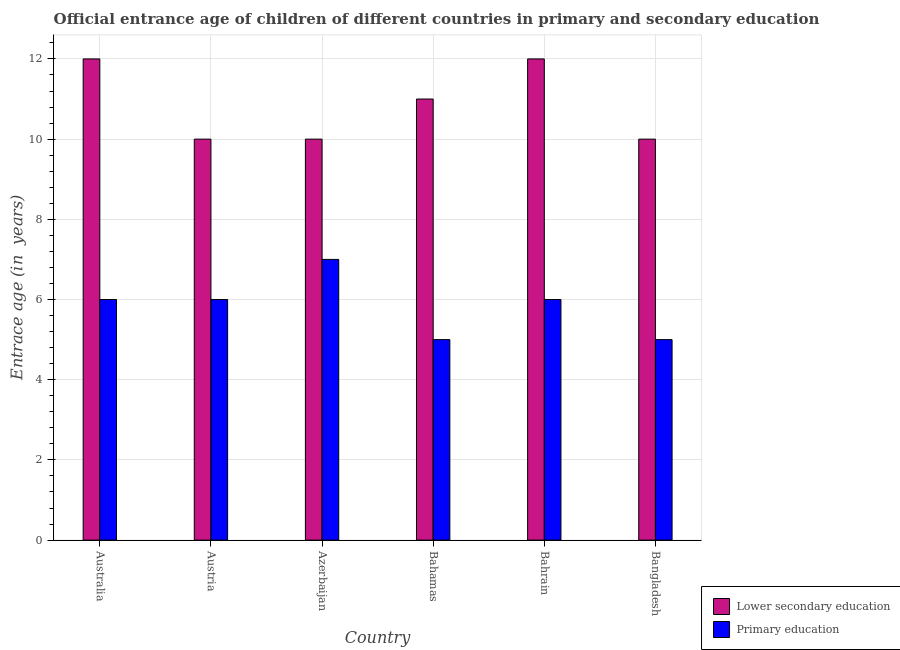Are the number of bars per tick equal to the number of legend labels?
Give a very brief answer. Yes. Are the number of bars on each tick of the X-axis equal?
Provide a short and direct response. Yes. How many bars are there on the 3rd tick from the right?
Offer a terse response. 2. What is the label of the 3rd group of bars from the left?
Your response must be concise. Azerbaijan. What is the entrance age of children in lower secondary education in Australia?
Your answer should be very brief. 12. Across all countries, what is the maximum entrance age of children in lower secondary education?
Ensure brevity in your answer.  12. Across all countries, what is the minimum entrance age of children in lower secondary education?
Ensure brevity in your answer.  10. In which country was the entrance age of chiildren in primary education maximum?
Ensure brevity in your answer.  Azerbaijan. In which country was the entrance age of children in lower secondary education minimum?
Offer a terse response. Austria. What is the total entrance age of chiildren in primary education in the graph?
Offer a very short reply. 35. What is the difference between the entrance age of chiildren in primary education in Bahrain and that in Bangladesh?
Your answer should be very brief. 1. What is the difference between the entrance age of children in lower secondary education in Australia and the entrance age of chiildren in primary education in Austria?
Offer a terse response. 6. What is the average entrance age of children in lower secondary education per country?
Make the answer very short. 10.83. In how many countries, is the entrance age of children in lower secondary education greater than 3.6 years?
Keep it short and to the point. 6. What is the ratio of the entrance age of children in lower secondary education in Bahamas to that in Bahrain?
Offer a terse response. 0.92. Is the difference between the entrance age of chiildren in primary education in Austria and Bahamas greater than the difference between the entrance age of children in lower secondary education in Austria and Bahamas?
Offer a terse response. Yes. What is the difference between the highest and the second highest entrance age of chiildren in primary education?
Provide a succinct answer. 1. What is the difference between the highest and the lowest entrance age of children in lower secondary education?
Your answer should be very brief. 2. What does the 1st bar from the left in Austria represents?
Your answer should be compact. Lower secondary education. What does the 1st bar from the right in Bahrain represents?
Keep it short and to the point. Primary education. What is the difference between two consecutive major ticks on the Y-axis?
Offer a terse response. 2. Does the graph contain any zero values?
Your answer should be very brief. No. Where does the legend appear in the graph?
Your answer should be very brief. Bottom right. How are the legend labels stacked?
Offer a terse response. Vertical. What is the title of the graph?
Ensure brevity in your answer.  Official entrance age of children of different countries in primary and secondary education. What is the label or title of the Y-axis?
Your response must be concise. Entrace age (in  years). What is the Entrace age (in  years) of Primary education in Australia?
Ensure brevity in your answer.  6. What is the Entrace age (in  years) of Lower secondary education in Austria?
Keep it short and to the point. 10. What is the Entrace age (in  years) in Primary education in Austria?
Offer a terse response. 6. What is the Entrace age (in  years) of Primary education in Bahamas?
Offer a terse response. 5. What is the Entrace age (in  years) in Lower secondary education in Bahrain?
Provide a short and direct response. 12. What is the Entrace age (in  years) in Lower secondary education in Bangladesh?
Make the answer very short. 10. What is the Entrace age (in  years) in Primary education in Bangladesh?
Your response must be concise. 5. Across all countries, what is the maximum Entrace age (in  years) of Primary education?
Provide a short and direct response. 7. Across all countries, what is the minimum Entrace age (in  years) of Lower secondary education?
Offer a terse response. 10. What is the total Entrace age (in  years) of Lower secondary education in the graph?
Provide a succinct answer. 65. What is the total Entrace age (in  years) in Primary education in the graph?
Make the answer very short. 35. What is the difference between the Entrace age (in  years) of Primary education in Australia and that in Austria?
Your answer should be compact. 0. What is the difference between the Entrace age (in  years) in Lower secondary education in Australia and that in Azerbaijan?
Your answer should be compact. 2. What is the difference between the Entrace age (in  years) of Primary education in Australia and that in Azerbaijan?
Keep it short and to the point. -1. What is the difference between the Entrace age (in  years) in Lower secondary education in Australia and that in Bahamas?
Provide a succinct answer. 1. What is the difference between the Entrace age (in  years) of Lower secondary education in Australia and that in Bahrain?
Provide a succinct answer. 0. What is the difference between the Entrace age (in  years) in Primary education in Australia and that in Bahrain?
Your response must be concise. 0. What is the difference between the Entrace age (in  years) in Lower secondary education in Australia and that in Bangladesh?
Your answer should be compact. 2. What is the difference between the Entrace age (in  years) in Lower secondary education in Austria and that in Azerbaijan?
Provide a succinct answer. 0. What is the difference between the Entrace age (in  years) in Lower secondary education in Austria and that in Bahamas?
Keep it short and to the point. -1. What is the difference between the Entrace age (in  years) of Lower secondary education in Austria and that in Bahrain?
Offer a very short reply. -2. What is the difference between the Entrace age (in  years) in Lower secondary education in Azerbaijan and that in Bahamas?
Ensure brevity in your answer.  -1. What is the difference between the Entrace age (in  years) in Primary education in Azerbaijan and that in Bahamas?
Keep it short and to the point. 2. What is the difference between the Entrace age (in  years) in Primary education in Azerbaijan and that in Bahrain?
Offer a terse response. 1. What is the difference between the Entrace age (in  years) in Primary education in Azerbaijan and that in Bangladesh?
Ensure brevity in your answer.  2. What is the difference between the Entrace age (in  years) of Lower secondary education in Bahamas and that in Bahrain?
Give a very brief answer. -1. What is the difference between the Entrace age (in  years) in Primary education in Bahamas and that in Bahrain?
Provide a succinct answer. -1. What is the difference between the Entrace age (in  years) of Lower secondary education in Bahrain and that in Bangladesh?
Provide a succinct answer. 2. What is the difference between the Entrace age (in  years) of Lower secondary education in Australia and the Entrace age (in  years) of Primary education in Bahamas?
Offer a very short reply. 7. What is the difference between the Entrace age (in  years) in Lower secondary education in Australia and the Entrace age (in  years) in Primary education in Bahrain?
Keep it short and to the point. 6. What is the difference between the Entrace age (in  years) in Lower secondary education in Austria and the Entrace age (in  years) in Primary education in Azerbaijan?
Provide a short and direct response. 3. What is the difference between the Entrace age (in  years) of Lower secondary education in Austria and the Entrace age (in  years) of Primary education in Bahamas?
Give a very brief answer. 5. What is the difference between the Entrace age (in  years) in Lower secondary education in Austria and the Entrace age (in  years) in Primary education in Bahrain?
Your response must be concise. 4. What is the difference between the Entrace age (in  years) of Lower secondary education in Azerbaijan and the Entrace age (in  years) of Primary education in Bahamas?
Keep it short and to the point. 5. What is the difference between the Entrace age (in  years) of Lower secondary education in Bahamas and the Entrace age (in  years) of Primary education in Bangladesh?
Your answer should be very brief. 6. What is the average Entrace age (in  years) in Lower secondary education per country?
Keep it short and to the point. 10.83. What is the average Entrace age (in  years) in Primary education per country?
Provide a succinct answer. 5.83. What is the difference between the Entrace age (in  years) in Lower secondary education and Entrace age (in  years) in Primary education in Australia?
Provide a succinct answer. 6. What is the difference between the Entrace age (in  years) in Lower secondary education and Entrace age (in  years) in Primary education in Bahamas?
Provide a short and direct response. 6. What is the difference between the Entrace age (in  years) in Lower secondary education and Entrace age (in  years) in Primary education in Bangladesh?
Your response must be concise. 5. What is the ratio of the Entrace age (in  years) in Lower secondary education in Australia to that in Austria?
Keep it short and to the point. 1.2. What is the ratio of the Entrace age (in  years) of Primary education in Australia to that in Austria?
Your response must be concise. 1. What is the ratio of the Entrace age (in  years) of Lower secondary education in Australia to that in Azerbaijan?
Offer a terse response. 1.2. What is the ratio of the Entrace age (in  years) of Lower secondary education in Australia to that in Bahamas?
Make the answer very short. 1.09. What is the ratio of the Entrace age (in  years) of Lower secondary education in Australia to that in Bahrain?
Offer a very short reply. 1. What is the ratio of the Entrace age (in  years) of Primary education in Australia to that in Bangladesh?
Offer a very short reply. 1.2. What is the ratio of the Entrace age (in  years) in Lower secondary education in Austria to that in Bahamas?
Your answer should be compact. 0.91. What is the ratio of the Entrace age (in  years) of Lower secondary education in Austria to that in Bahrain?
Offer a terse response. 0.83. What is the ratio of the Entrace age (in  years) in Lower secondary education in Austria to that in Bangladesh?
Give a very brief answer. 1. What is the ratio of the Entrace age (in  years) of Primary education in Austria to that in Bangladesh?
Make the answer very short. 1.2. What is the ratio of the Entrace age (in  years) in Lower secondary education in Azerbaijan to that in Bahamas?
Provide a short and direct response. 0.91. What is the ratio of the Entrace age (in  years) of Primary education in Azerbaijan to that in Bahrain?
Your answer should be very brief. 1.17. What is the ratio of the Entrace age (in  years) in Primary education in Azerbaijan to that in Bangladesh?
Keep it short and to the point. 1.4. What is the ratio of the Entrace age (in  years) in Primary education in Bahamas to that in Bahrain?
Make the answer very short. 0.83. What is the ratio of the Entrace age (in  years) in Primary education in Bahamas to that in Bangladesh?
Ensure brevity in your answer.  1. What is the ratio of the Entrace age (in  years) in Lower secondary education in Bahrain to that in Bangladesh?
Make the answer very short. 1.2. What is the ratio of the Entrace age (in  years) of Primary education in Bahrain to that in Bangladesh?
Your response must be concise. 1.2. 